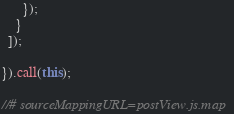<code> <loc_0><loc_0><loc_500><loc_500><_JavaScript_>      });
    }
  ]);

}).call(this);

//# sourceMappingURL=postView.js.map
</code> 